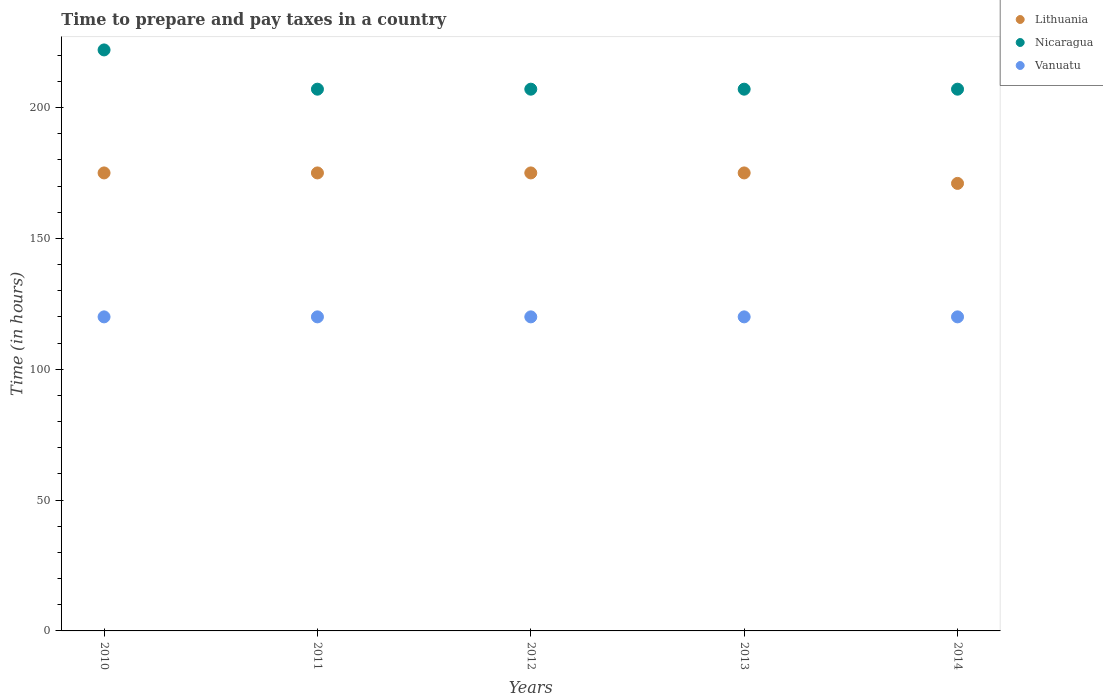How many different coloured dotlines are there?
Offer a very short reply. 3. Is the number of dotlines equal to the number of legend labels?
Make the answer very short. Yes. What is the number of hours required to prepare and pay taxes in Vanuatu in 2010?
Your answer should be very brief. 120. Across all years, what is the maximum number of hours required to prepare and pay taxes in Vanuatu?
Ensure brevity in your answer.  120. Across all years, what is the minimum number of hours required to prepare and pay taxes in Vanuatu?
Provide a succinct answer. 120. In which year was the number of hours required to prepare and pay taxes in Nicaragua maximum?
Keep it short and to the point. 2010. In which year was the number of hours required to prepare and pay taxes in Nicaragua minimum?
Make the answer very short. 2011. What is the total number of hours required to prepare and pay taxes in Nicaragua in the graph?
Your answer should be very brief. 1050. What is the difference between the number of hours required to prepare and pay taxes in Nicaragua in 2014 and the number of hours required to prepare and pay taxes in Vanuatu in 2010?
Ensure brevity in your answer.  87. What is the average number of hours required to prepare and pay taxes in Nicaragua per year?
Your answer should be very brief. 210. In the year 2011, what is the difference between the number of hours required to prepare and pay taxes in Vanuatu and number of hours required to prepare and pay taxes in Lithuania?
Your answer should be very brief. -55. What is the ratio of the number of hours required to prepare and pay taxes in Lithuania in 2011 to that in 2014?
Your response must be concise. 1.02. Is the number of hours required to prepare and pay taxes in Vanuatu in 2010 less than that in 2012?
Your response must be concise. No. Is the difference between the number of hours required to prepare and pay taxes in Vanuatu in 2010 and 2011 greater than the difference between the number of hours required to prepare and pay taxes in Lithuania in 2010 and 2011?
Make the answer very short. No. What is the difference between the highest and the lowest number of hours required to prepare and pay taxes in Lithuania?
Provide a short and direct response. 4. Is it the case that in every year, the sum of the number of hours required to prepare and pay taxes in Nicaragua and number of hours required to prepare and pay taxes in Lithuania  is greater than the number of hours required to prepare and pay taxes in Vanuatu?
Provide a succinct answer. Yes. Does the number of hours required to prepare and pay taxes in Lithuania monotonically increase over the years?
Ensure brevity in your answer.  No. Is the number of hours required to prepare and pay taxes in Lithuania strictly greater than the number of hours required to prepare and pay taxes in Nicaragua over the years?
Keep it short and to the point. No. Are the values on the major ticks of Y-axis written in scientific E-notation?
Your response must be concise. No. How many legend labels are there?
Offer a terse response. 3. How are the legend labels stacked?
Ensure brevity in your answer.  Vertical. What is the title of the graph?
Your response must be concise. Time to prepare and pay taxes in a country. What is the label or title of the X-axis?
Provide a succinct answer. Years. What is the label or title of the Y-axis?
Provide a succinct answer. Time (in hours). What is the Time (in hours) in Lithuania in 2010?
Your answer should be compact. 175. What is the Time (in hours) of Nicaragua in 2010?
Ensure brevity in your answer.  222. What is the Time (in hours) in Vanuatu in 2010?
Give a very brief answer. 120. What is the Time (in hours) in Lithuania in 2011?
Keep it short and to the point. 175. What is the Time (in hours) in Nicaragua in 2011?
Ensure brevity in your answer.  207. What is the Time (in hours) in Vanuatu in 2011?
Offer a terse response. 120. What is the Time (in hours) of Lithuania in 2012?
Keep it short and to the point. 175. What is the Time (in hours) of Nicaragua in 2012?
Provide a short and direct response. 207. What is the Time (in hours) of Vanuatu in 2012?
Keep it short and to the point. 120. What is the Time (in hours) of Lithuania in 2013?
Your answer should be compact. 175. What is the Time (in hours) of Nicaragua in 2013?
Give a very brief answer. 207. What is the Time (in hours) of Vanuatu in 2013?
Offer a very short reply. 120. What is the Time (in hours) in Lithuania in 2014?
Offer a terse response. 171. What is the Time (in hours) of Nicaragua in 2014?
Your answer should be compact. 207. What is the Time (in hours) of Vanuatu in 2014?
Your answer should be very brief. 120. Across all years, what is the maximum Time (in hours) of Lithuania?
Keep it short and to the point. 175. Across all years, what is the maximum Time (in hours) of Nicaragua?
Your answer should be compact. 222. Across all years, what is the maximum Time (in hours) of Vanuatu?
Your answer should be compact. 120. Across all years, what is the minimum Time (in hours) in Lithuania?
Offer a terse response. 171. Across all years, what is the minimum Time (in hours) of Nicaragua?
Provide a succinct answer. 207. Across all years, what is the minimum Time (in hours) in Vanuatu?
Provide a succinct answer. 120. What is the total Time (in hours) of Lithuania in the graph?
Make the answer very short. 871. What is the total Time (in hours) of Nicaragua in the graph?
Ensure brevity in your answer.  1050. What is the total Time (in hours) of Vanuatu in the graph?
Keep it short and to the point. 600. What is the difference between the Time (in hours) in Vanuatu in 2010 and that in 2011?
Your answer should be very brief. 0. What is the difference between the Time (in hours) in Nicaragua in 2010 and that in 2012?
Ensure brevity in your answer.  15. What is the difference between the Time (in hours) of Vanuatu in 2010 and that in 2013?
Make the answer very short. 0. What is the difference between the Time (in hours) in Nicaragua in 2010 and that in 2014?
Offer a very short reply. 15. What is the difference between the Time (in hours) of Lithuania in 2011 and that in 2013?
Your answer should be compact. 0. What is the difference between the Time (in hours) of Vanuatu in 2011 and that in 2013?
Offer a very short reply. 0. What is the difference between the Time (in hours) in Lithuania in 2011 and that in 2014?
Your answer should be very brief. 4. What is the difference between the Time (in hours) in Vanuatu in 2011 and that in 2014?
Keep it short and to the point. 0. What is the difference between the Time (in hours) in Lithuania in 2012 and that in 2014?
Make the answer very short. 4. What is the difference between the Time (in hours) in Nicaragua in 2012 and that in 2014?
Your answer should be very brief. 0. What is the difference between the Time (in hours) in Nicaragua in 2013 and that in 2014?
Make the answer very short. 0. What is the difference between the Time (in hours) in Vanuatu in 2013 and that in 2014?
Ensure brevity in your answer.  0. What is the difference between the Time (in hours) in Lithuania in 2010 and the Time (in hours) in Nicaragua in 2011?
Ensure brevity in your answer.  -32. What is the difference between the Time (in hours) in Nicaragua in 2010 and the Time (in hours) in Vanuatu in 2011?
Provide a short and direct response. 102. What is the difference between the Time (in hours) in Lithuania in 2010 and the Time (in hours) in Nicaragua in 2012?
Offer a terse response. -32. What is the difference between the Time (in hours) of Nicaragua in 2010 and the Time (in hours) of Vanuatu in 2012?
Provide a succinct answer. 102. What is the difference between the Time (in hours) of Lithuania in 2010 and the Time (in hours) of Nicaragua in 2013?
Ensure brevity in your answer.  -32. What is the difference between the Time (in hours) in Lithuania in 2010 and the Time (in hours) in Vanuatu in 2013?
Give a very brief answer. 55. What is the difference between the Time (in hours) in Nicaragua in 2010 and the Time (in hours) in Vanuatu in 2013?
Keep it short and to the point. 102. What is the difference between the Time (in hours) of Lithuania in 2010 and the Time (in hours) of Nicaragua in 2014?
Your answer should be very brief. -32. What is the difference between the Time (in hours) in Lithuania in 2010 and the Time (in hours) in Vanuatu in 2014?
Keep it short and to the point. 55. What is the difference between the Time (in hours) in Nicaragua in 2010 and the Time (in hours) in Vanuatu in 2014?
Provide a short and direct response. 102. What is the difference between the Time (in hours) of Lithuania in 2011 and the Time (in hours) of Nicaragua in 2012?
Offer a very short reply. -32. What is the difference between the Time (in hours) in Lithuania in 2011 and the Time (in hours) in Nicaragua in 2013?
Provide a short and direct response. -32. What is the difference between the Time (in hours) of Lithuania in 2011 and the Time (in hours) of Vanuatu in 2013?
Offer a terse response. 55. What is the difference between the Time (in hours) of Lithuania in 2011 and the Time (in hours) of Nicaragua in 2014?
Your answer should be very brief. -32. What is the difference between the Time (in hours) of Lithuania in 2011 and the Time (in hours) of Vanuatu in 2014?
Your answer should be compact. 55. What is the difference between the Time (in hours) of Lithuania in 2012 and the Time (in hours) of Nicaragua in 2013?
Ensure brevity in your answer.  -32. What is the difference between the Time (in hours) in Lithuania in 2012 and the Time (in hours) in Nicaragua in 2014?
Offer a very short reply. -32. What is the difference between the Time (in hours) in Nicaragua in 2012 and the Time (in hours) in Vanuatu in 2014?
Give a very brief answer. 87. What is the difference between the Time (in hours) in Lithuania in 2013 and the Time (in hours) in Nicaragua in 2014?
Offer a terse response. -32. What is the difference between the Time (in hours) in Nicaragua in 2013 and the Time (in hours) in Vanuatu in 2014?
Offer a very short reply. 87. What is the average Time (in hours) in Lithuania per year?
Make the answer very short. 174.2. What is the average Time (in hours) of Nicaragua per year?
Provide a short and direct response. 210. What is the average Time (in hours) of Vanuatu per year?
Your answer should be compact. 120. In the year 2010, what is the difference between the Time (in hours) of Lithuania and Time (in hours) of Nicaragua?
Provide a short and direct response. -47. In the year 2010, what is the difference between the Time (in hours) in Nicaragua and Time (in hours) in Vanuatu?
Keep it short and to the point. 102. In the year 2011, what is the difference between the Time (in hours) in Lithuania and Time (in hours) in Nicaragua?
Your response must be concise. -32. In the year 2011, what is the difference between the Time (in hours) in Lithuania and Time (in hours) in Vanuatu?
Provide a succinct answer. 55. In the year 2011, what is the difference between the Time (in hours) of Nicaragua and Time (in hours) of Vanuatu?
Give a very brief answer. 87. In the year 2012, what is the difference between the Time (in hours) in Lithuania and Time (in hours) in Nicaragua?
Offer a very short reply. -32. In the year 2012, what is the difference between the Time (in hours) of Lithuania and Time (in hours) of Vanuatu?
Your answer should be compact. 55. In the year 2012, what is the difference between the Time (in hours) in Nicaragua and Time (in hours) in Vanuatu?
Give a very brief answer. 87. In the year 2013, what is the difference between the Time (in hours) of Lithuania and Time (in hours) of Nicaragua?
Keep it short and to the point. -32. In the year 2013, what is the difference between the Time (in hours) in Lithuania and Time (in hours) in Vanuatu?
Offer a terse response. 55. In the year 2014, what is the difference between the Time (in hours) of Lithuania and Time (in hours) of Nicaragua?
Provide a short and direct response. -36. In the year 2014, what is the difference between the Time (in hours) in Lithuania and Time (in hours) in Vanuatu?
Your response must be concise. 51. What is the ratio of the Time (in hours) in Lithuania in 2010 to that in 2011?
Provide a succinct answer. 1. What is the ratio of the Time (in hours) of Nicaragua in 2010 to that in 2011?
Provide a short and direct response. 1.07. What is the ratio of the Time (in hours) of Vanuatu in 2010 to that in 2011?
Offer a terse response. 1. What is the ratio of the Time (in hours) of Nicaragua in 2010 to that in 2012?
Keep it short and to the point. 1.07. What is the ratio of the Time (in hours) of Vanuatu in 2010 to that in 2012?
Your response must be concise. 1. What is the ratio of the Time (in hours) in Lithuania in 2010 to that in 2013?
Ensure brevity in your answer.  1. What is the ratio of the Time (in hours) in Nicaragua in 2010 to that in 2013?
Your answer should be very brief. 1.07. What is the ratio of the Time (in hours) of Vanuatu in 2010 to that in 2013?
Your answer should be very brief. 1. What is the ratio of the Time (in hours) in Lithuania in 2010 to that in 2014?
Offer a terse response. 1.02. What is the ratio of the Time (in hours) in Nicaragua in 2010 to that in 2014?
Your answer should be compact. 1.07. What is the ratio of the Time (in hours) in Vanuatu in 2010 to that in 2014?
Provide a short and direct response. 1. What is the ratio of the Time (in hours) in Lithuania in 2011 to that in 2012?
Offer a terse response. 1. What is the ratio of the Time (in hours) in Nicaragua in 2011 to that in 2012?
Your answer should be compact. 1. What is the ratio of the Time (in hours) in Lithuania in 2011 to that in 2013?
Your response must be concise. 1. What is the ratio of the Time (in hours) of Nicaragua in 2011 to that in 2013?
Provide a short and direct response. 1. What is the ratio of the Time (in hours) of Lithuania in 2011 to that in 2014?
Provide a succinct answer. 1.02. What is the ratio of the Time (in hours) in Nicaragua in 2011 to that in 2014?
Ensure brevity in your answer.  1. What is the ratio of the Time (in hours) in Vanuatu in 2011 to that in 2014?
Ensure brevity in your answer.  1. What is the ratio of the Time (in hours) in Lithuania in 2012 to that in 2013?
Your answer should be very brief. 1. What is the ratio of the Time (in hours) of Lithuania in 2012 to that in 2014?
Offer a terse response. 1.02. What is the ratio of the Time (in hours) of Nicaragua in 2012 to that in 2014?
Keep it short and to the point. 1. What is the ratio of the Time (in hours) in Vanuatu in 2012 to that in 2014?
Provide a succinct answer. 1. What is the ratio of the Time (in hours) in Lithuania in 2013 to that in 2014?
Your answer should be compact. 1.02. What is the ratio of the Time (in hours) of Nicaragua in 2013 to that in 2014?
Your answer should be compact. 1. What is the difference between the highest and the second highest Time (in hours) of Nicaragua?
Offer a very short reply. 15. What is the difference between the highest and the second highest Time (in hours) of Vanuatu?
Give a very brief answer. 0. What is the difference between the highest and the lowest Time (in hours) in Lithuania?
Give a very brief answer. 4. What is the difference between the highest and the lowest Time (in hours) in Nicaragua?
Your answer should be compact. 15. 